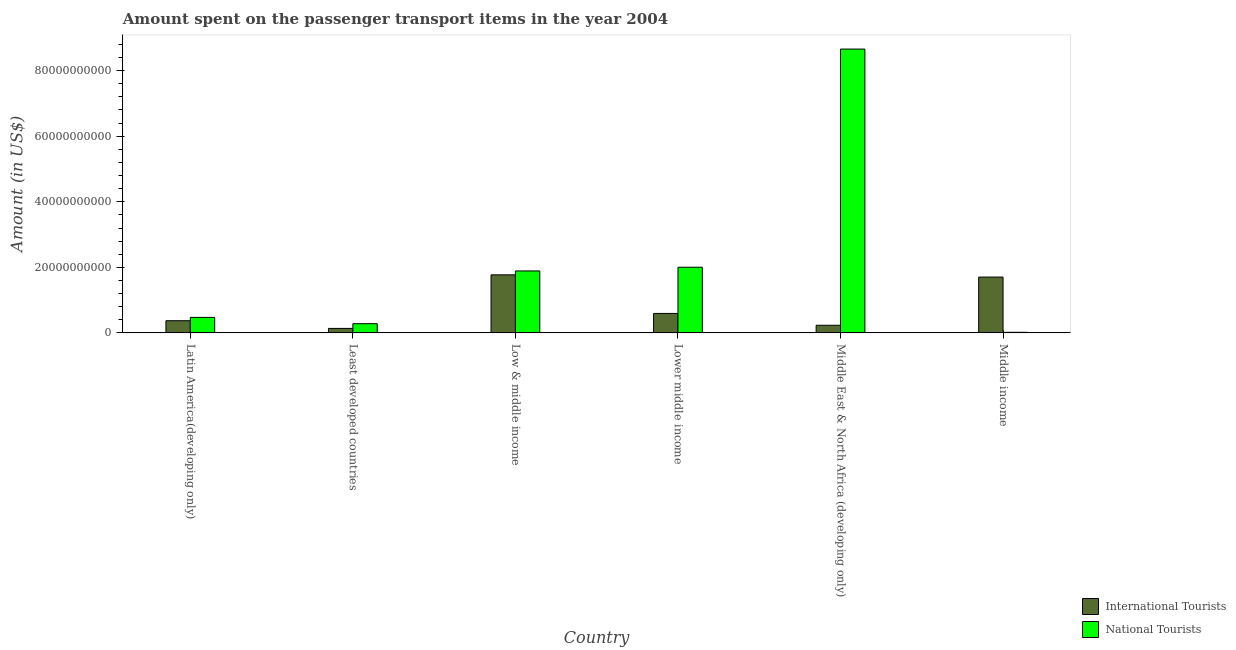How many groups of bars are there?
Provide a succinct answer. 6. Are the number of bars per tick equal to the number of legend labels?
Your answer should be compact. Yes. Are the number of bars on each tick of the X-axis equal?
Provide a succinct answer. Yes. What is the label of the 4th group of bars from the left?
Offer a terse response. Lower middle income. What is the amount spent on transport items of national tourists in Low & middle income?
Keep it short and to the point. 1.89e+1. Across all countries, what is the maximum amount spent on transport items of international tourists?
Your answer should be very brief. 1.77e+1. Across all countries, what is the minimum amount spent on transport items of national tourists?
Provide a short and direct response. 1.92e+08. In which country was the amount spent on transport items of national tourists maximum?
Offer a very short reply. Middle East & North Africa (developing only). In which country was the amount spent on transport items of international tourists minimum?
Offer a terse response. Least developed countries. What is the total amount spent on transport items of national tourists in the graph?
Ensure brevity in your answer.  1.33e+11. What is the difference between the amount spent on transport items of international tourists in Latin America(developing only) and that in Lower middle income?
Provide a short and direct response. -2.22e+09. What is the difference between the amount spent on transport items of international tourists in Lower middle income and the amount spent on transport items of national tourists in Middle income?
Provide a short and direct response. 5.76e+09. What is the average amount spent on transport items of international tourists per country?
Keep it short and to the point. 8.03e+09. What is the difference between the amount spent on transport items of national tourists and amount spent on transport items of international tourists in Low & middle income?
Ensure brevity in your answer.  1.19e+09. What is the ratio of the amount spent on transport items of international tourists in Low & middle income to that in Middle East & North Africa (developing only)?
Offer a terse response. 7.56. Is the amount spent on transport items of international tourists in Latin America(developing only) less than that in Least developed countries?
Offer a terse response. No. What is the difference between the highest and the second highest amount spent on transport items of national tourists?
Keep it short and to the point. 6.65e+1. What is the difference between the highest and the lowest amount spent on transport items of international tourists?
Offer a terse response. 1.63e+1. In how many countries, is the amount spent on transport items of national tourists greater than the average amount spent on transport items of national tourists taken over all countries?
Offer a very short reply. 1. Is the sum of the amount spent on transport items of international tourists in Least developed countries and Middle East & North Africa (developing only) greater than the maximum amount spent on transport items of national tourists across all countries?
Your answer should be very brief. No. What does the 2nd bar from the left in Middle East & North Africa (developing only) represents?
Offer a very short reply. National Tourists. What does the 2nd bar from the right in Middle East & North Africa (developing only) represents?
Your response must be concise. International Tourists. Are all the bars in the graph horizontal?
Give a very brief answer. No. Does the graph contain any zero values?
Your answer should be compact. No. Does the graph contain grids?
Keep it short and to the point. No. How many legend labels are there?
Give a very brief answer. 2. What is the title of the graph?
Offer a very short reply. Amount spent on the passenger transport items in the year 2004. What is the label or title of the X-axis?
Provide a short and direct response. Country. What is the label or title of the Y-axis?
Offer a terse response. Amount (in US$). What is the Amount (in US$) of International Tourists in Latin America(developing only)?
Make the answer very short. 3.73e+09. What is the Amount (in US$) of National Tourists in Latin America(developing only)?
Your answer should be very brief. 4.74e+09. What is the Amount (in US$) in International Tourists in Least developed countries?
Your answer should be compact. 1.38e+09. What is the Amount (in US$) in National Tourists in Least developed countries?
Your answer should be very brief. 2.82e+09. What is the Amount (in US$) of International Tourists in Low & middle income?
Your answer should be very brief. 1.77e+1. What is the Amount (in US$) of National Tourists in Low & middle income?
Make the answer very short. 1.89e+1. What is the Amount (in US$) of International Tourists in Lower middle income?
Your answer should be very brief. 5.95e+09. What is the Amount (in US$) of National Tourists in Lower middle income?
Offer a terse response. 2.00e+1. What is the Amount (in US$) in International Tourists in Middle East & North Africa (developing only)?
Your response must be concise. 2.34e+09. What is the Amount (in US$) of National Tourists in Middle East & North Africa (developing only)?
Keep it short and to the point. 8.66e+1. What is the Amount (in US$) in International Tourists in Middle income?
Your answer should be very brief. 1.70e+1. What is the Amount (in US$) in National Tourists in Middle income?
Your answer should be very brief. 1.92e+08. Across all countries, what is the maximum Amount (in US$) in International Tourists?
Make the answer very short. 1.77e+1. Across all countries, what is the maximum Amount (in US$) in National Tourists?
Your answer should be compact. 8.66e+1. Across all countries, what is the minimum Amount (in US$) of International Tourists?
Offer a very short reply. 1.38e+09. Across all countries, what is the minimum Amount (in US$) of National Tourists?
Your answer should be very brief. 1.92e+08. What is the total Amount (in US$) in International Tourists in the graph?
Make the answer very short. 4.82e+1. What is the total Amount (in US$) of National Tourists in the graph?
Make the answer very short. 1.33e+11. What is the difference between the Amount (in US$) in International Tourists in Latin America(developing only) and that in Least developed countries?
Give a very brief answer. 2.35e+09. What is the difference between the Amount (in US$) in National Tourists in Latin America(developing only) and that in Least developed countries?
Give a very brief answer. 1.92e+09. What is the difference between the Amount (in US$) in International Tourists in Latin America(developing only) and that in Low & middle income?
Keep it short and to the point. -1.40e+1. What is the difference between the Amount (in US$) of National Tourists in Latin America(developing only) and that in Low & middle income?
Provide a short and direct response. -1.42e+1. What is the difference between the Amount (in US$) in International Tourists in Latin America(developing only) and that in Lower middle income?
Your answer should be very brief. -2.22e+09. What is the difference between the Amount (in US$) of National Tourists in Latin America(developing only) and that in Lower middle income?
Give a very brief answer. -1.53e+1. What is the difference between the Amount (in US$) of International Tourists in Latin America(developing only) and that in Middle East & North Africa (developing only)?
Provide a succinct answer. 1.39e+09. What is the difference between the Amount (in US$) in National Tourists in Latin America(developing only) and that in Middle East & North Africa (developing only)?
Provide a succinct answer. -8.18e+1. What is the difference between the Amount (in US$) in International Tourists in Latin America(developing only) and that in Middle income?
Offer a terse response. -1.33e+1. What is the difference between the Amount (in US$) of National Tourists in Latin America(developing only) and that in Middle income?
Provide a succinct answer. 4.55e+09. What is the difference between the Amount (in US$) of International Tourists in Least developed countries and that in Low & middle income?
Your answer should be compact. -1.63e+1. What is the difference between the Amount (in US$) of National Tourists in Least developed countries and that in Low & middle income?
Keep it short and to the point. -1.61e+1. What is the difference between the Amount (in US$) in International Tourists in Least developed countries and that in Lower middle income?
Provide a short and direct response. -4.57e+09. What is the difference between the Amount (in US$) of National Tourists in Least developed countries and that in Lower middle income?
Ensure brevity in your answer.  -1.72e+1. What is the difference between the Amount (in US$) of International Tourists in Least developed countries and that in Middle East & North Africa (developing only)?
Your answer should be very brief. -9.63e+08. What is the difference between the Amount (in US$) in National Tourists in Least developed countries and that in Middle East & North Africa (developing only)?
Provide a short and direct response. -8.38e+1. What is the difference between the Amount (in US$) in International Tourists in Least developed countries and that in Middle income?
Provide a short and direct response. -1.57e+1. What is the difference between the Amount (in US$) of National Tourists in Least developed countries and that in Middle income?
Provide a succinct answer. 2.63e+09. What is the difference between the Amount (in US$) of International Tourists in Low & middle income and that in Lower middle income?
Ensure brevity in your answer.  1.18e+1. What is the difference between the Amount (in US$) in National Tourists in Low & middle income and that in Lower middle income?
Make the answer very short. -1.13e+09. What is the difference between the Amount (in US$) in International Tourists in Low & middle income and that in Middle East & North Africa (developing only)?
Give a very brief answer. 1.54e+1. What is the difference between the Amount (in US$) of National Tourists in Low & middle income and that in Middle East & North Africa (developing only)?
Give a very brief answer. -6.77e+1. What is the difference between the Amount (in US$) in International Tourists in Low & middle income and that in Middle income?
Provide a short and direct response. 6.77e+08. What is the difference between the Amount (in US$) of National Tourists in Low & middle income and that in Middle income?
Your response must be concise. 1.87e+1. What is the difference between the Amount (in US$) of International Tourists in Lower middle income and that in Middle East & North Africa (developing only)?
Offer a very short reply. 3.61e+09. What is the difference between the Amount (in US$) of National Tourists in Lower middle income and that in Middle East & North Africa (developing only)?
Offer a very short reply. -6.65e+1. What is the difference between the Amount (in US$) of International Tourists in Lower middle income and that in Middle income?
Provide a succinct answer. -1.11e+1. What is the difference between the Amount (in US$) in National Tourists in Lower middle income and that in Middle income?
Provide a succinct answer. 1.98e+1. What is the difference between the Amount (in US$) of International Tourists in Middle East & North Africa (developing only) and that in Middle income?
Your answer should be compact. -1.47e+1. What is the difference between the Amount (in US$) of National Tourists in Middle East & North Africa (developing only) and that in Middle income?
Offer a very short reply. 8.64e+1. What is the difference between the Amount (in US$) in International Tourists in Latin America(developing only) and the Amount (in US$) in National Tourists in Least developed countries?
Offer a very short reply. 9.08e+08. What is the difference between the Amount (in US$) in International Tourists in Latin America(developing only) and the Amount (in US$) in National Tourists in Low & middle income?
Your response must be concise. -1.52e+1. What is the difference between the Amount (in US$) of International Tourists in Latin America(developing only) and the Amount (in US$) of National Tourists in Lower middle income?
Ensure brevity in your answer.  -1.63e+1. What is the difference between the Amount (in US$) in International Tourists in Latin America(developing only) and the Amount (in US$) in National Tourists in Middle East & North Africa (developing only)?
Make the answer very short. -8.29e+1. What is the difference between the Amount (in US$) of International Tourists in Latin America(developing only) and the Amount (in US$) of National Tourists in Middle income?
Make the answer very short. 3.54e+09. What is the difference between the Amount (in US$) in International Tourists in Least developed countries and the Amount (in US$) in National Tourists in Low & middle income?
Provide a succinct answer. -1.75e+1. What is the difference between the Amount (in US$) in International Tourists in Least developed countries and the Amount (in US$) in National Tourists in Lower middle income?
Offer a very short reply. -1.87e+1. What is the difference between the Amount (in US$) in International Tourists in Least developed countries and the Amount (in US$) in National Tourists in Middle East & North Africa (developing only)?
Offer a very short reply. -8.52e+1. What is the difference between the Amount (in US$) of International Tourists in Least developed countries and the Amount (in US$) of National Tourists in Middle income?
Your response must be concise. 1.19e+09. What is the difference between the Amount (in US$) in International Tourists in Low & middle income and the Amount (in US$) in National Tourists in Lower middle income?
Your answer should be very brief. -2.32e+09. What is the difference between the Amount (in US$) of International Tourists in Low & middle income and the Amount (in US$) of National Tourists in Middle East & North Africa (developing only)?
Give a very brief answer. -6.89e+1. What is the difference between the Amount (in US$) of International Tourists in Low & middle income and the Amount (in US$) of National Tourists in Middle income?
Keep it short and to the point. 1.75e+1. What is the difference between the Amount (in US$) in International Tourists in Lower middle income and the Amount (in US$) in National Tourists in Middle East & North Africa (developing only)?
Your answer should be very brief. -8.06e+1. What is the difference between the Amount (in US$) in International Tourists in Lower middle income and the Amount (in US$) in National Tourists in Middle income?
Give a very brief answer. 5.76e+09. What is the difference between the Amount (in US$) in International Tourists in Middle East & North Africa (developing only) and the Amount (in US$) in National Tourists in Middle income?
Keep it short and to the point. 2.15e+09. What is the average Amount (in US$) of International Tourists per country?
Provide a short and direct response. 8.03e+09. What is the average Amount (in US$) of National Tourists per country?
Your answer should be very brief. 2.22e+1. What is the difference between the Amount (in US$) in International Tourists and Amount (in US$) in National Tourists in Latin America(developing only)?
Your answer should be compact. -1.02e+09. What is the difference between the Amount (in US$) in International Tourists and Amount (in US$) in National Tourists in Least developed countries?
Your answer should be very brief. -1.44e+09. What is the difference between the Amount (in US$) in International Tourists and Amount (in US$) in National Tourists in Low & middle income?
Ensure brevity in your answer.  -1.19e+09. What is the difference between the Amount (in US$) in International Tourists and Amount (in US$) in National Tourists in Lower middle income?
Provide a succinct answer. -1.41e+1. What is the difference between the Amount (in US$) in International Tourists and Amount (in US$) in National Tourists in Middle East & North Africa (developing only)?
Offer a terse response. -8.42e+1. What is the difference between the Amount (in US$) of International Tourists and Amount (in US$) of National Tourists in Middle income?
Provide a succinct answer. 1.69e+1. What is the ratio of the Amount (in US$) in International Tourists in Latin America(developing only) to that in Least developed countries?
Your answer should be very brief. 2.7. What is the ratio of the Amount (in US$) in National Tourists in Latin America(developing only) to that in Least developed countries?
Make the answer very short. 1.68. What is the ratio of the Amount (in US$) of International Tourists in Latin America(developing only) to that in Low & middle income?
Your answer should be compact. 0.21. What is the ratio of the Amount (in US$) in National Tourists in Latin America(developing only) to that in Low & middle income?
Offer a very short reply. 0.25. What is the ratio of the Amount (in US$) in International Tourists in Latin America(developing only) to that in Lower middle income?
Your response must be concise. 0.63. What is the ratio of the Amount (in US$) of National Tourists in Latin America(developing only) to that in Lower middle income?
Your answer should be compact. 0.24. What is the ratio of the Amount (in US$) in International Tourists in Latin America(developing only) to that in Middle East & North Africa (developing only)?
Your response must be concise. 1.59. What is the ratio of the Amount (in US$) in National Tourists in Latin America(developing only) to that in Middle East & North Africa (developing only)?
Your answer should be compact. 0.05. What is the ratio of the Amount (in US$) of International Tourists in Latin America(developing only) to that in Middle income?
Ensure brevity in your answer.  0.22. What is the ratio of the Amount (in US$) in National Tourists in Latin America(developing only) to that in Middle income?
Your answer should be very brief. 24.76. What is the ratio of the Amount (in US$) of International Tourists in Least developed countries to that in Low & middle income?
Offer a very short reply. 0.08. What is the ratio of the Amount (in US$) in National Tourists in Least developed countries to that in Low & middle income?
Make the answer very short. 0.15. What is the ratio of the Amount (in US$) of International Tourists in Least developed countries to that in Lower middle income?
Keep it short and to the point. 0.23. What is the ratio of the Amount (in US$) in National Tourists in Least developed countries to that in Lower middle income?
Make the answer very short. 0.14. What is the ratio of the Amount (in US$) in International Tourists in Least developed countries to that in Middle East & North Africa (developing only)?
Keep it short and to the point. 0.59. What is the ratio of the Amount (in US$) in National Tourists in Least developed countries to that in Middle East & North Africa (developing only)?
Provide a short and direct response. 0.03. What is the ratio of the Amount (in US$) of International Tourists in Least developed countries to that in Middle income?
Your response must be concise. 0.08. What is the ratio of the Amount (in US$) of National Tourists in Least developed countries to that in Middle income?
Provide a short and direct response. 14.72. What is the ratio of the Amount (in US$) of International Tourists in Low & middle income to that in Lower middle income?
Ensure brevity in your answer.  2.98. What is the ratio of the Amount (in US$) of National Tourists in Low & middle income to that in Lower middle income?
Keep it short and to the point. 0.94. What is the ratio of the Amount (in US$) of International Tourists in Low & middle income to that in Middle East & North Africa (developing only)?
Your answer should be compact. 7.56. What is the ratio of the Amount (in US$) in National Tourists in Low & middle income to that in Middle East & North Africa (developing only)?
Make the answer very short. 0.22. What is the ratio of the Amount (in US$) in International Tourists in Low & middle income to that in Middle income?
Make the answer very short. 1.04. What is the ratio of the Amount (in US$) of National Tourists in Low & middle income to that in Middle income?
Make the answer very short. 98.67. What is the ratio of the Amount (in US$) of International Tourists in Lower middle income to that in Middle East & North Africa (developing only)?
Offer a very short reply. 2.54. What is the ratio of the Amount (in US$) of National Tourists in Lower middle income to that in Middle East & North Africa (developing only)?
Your answer should be compact. 0.23. What is the ratio of the Amount (in US$) of International Tourists in Lower middle income to that in Middle income?
Your answer should be compact. 0.35. What is the ratio of the Amount (in US$) in National Tourists in Lower middle income to that in Middle income?
Keep it short and to the point. 104.58. What is the ratio of the Amount (in US$) in International Tourists in Middle East & North Africa (developing only) to that in Middle income?
Offer a terse response. 0.14. What is the ratio of the Amount (in US$) in National Tourists in Middle East & North Africa (developing only) to that in Middle income?
Keep it short and to the point. 451.86. What is the difference between the highest and the second highest Amount (in US$) of International Tourists?
Give a very brief answer. 6.77e+08. What is the difference between the highest and the second highest Amount (in US$) of National Tourists?
Provide a short and direct response. 6.65e+1. What is the difference between the highest and the lowest Amount (in US$) of International Tourists?
Provide a succinct answer. 1.63e+1. What is the difference between the highest and the lowest Amount (in US$) in National Tourists?
Keep it short and to the point. 8.64e+1. 